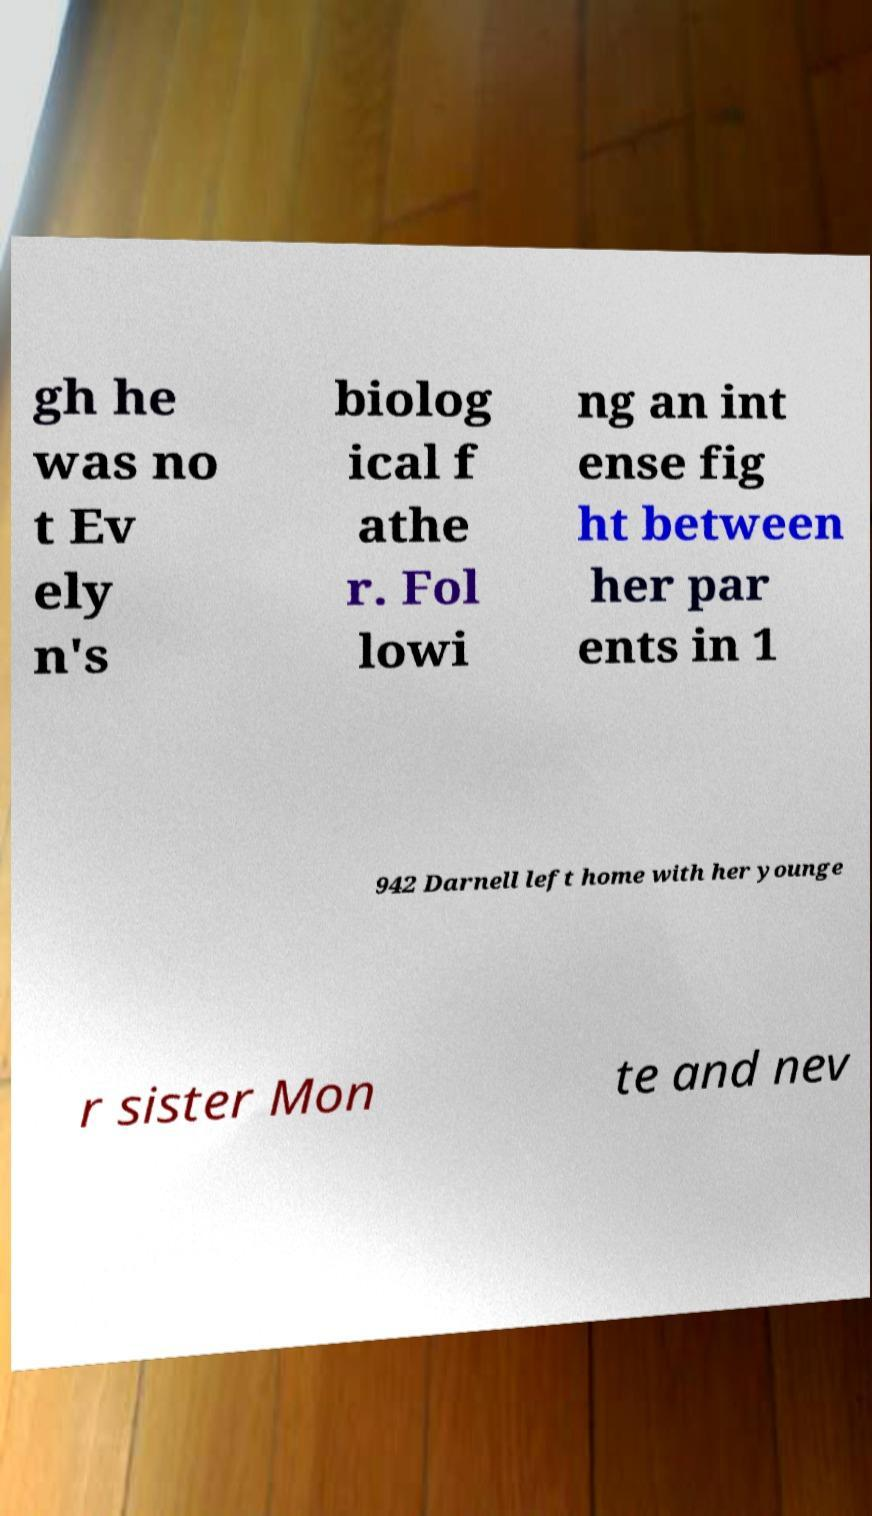Can you accurately transcribe the text from the provided image for me? gh he was no t Ev ely n's biolog ical f athe r. Fol lowi ng an int ense fig ht between her par ents in 1 942 Darnell left home with her younge r sister Mon te and nev 